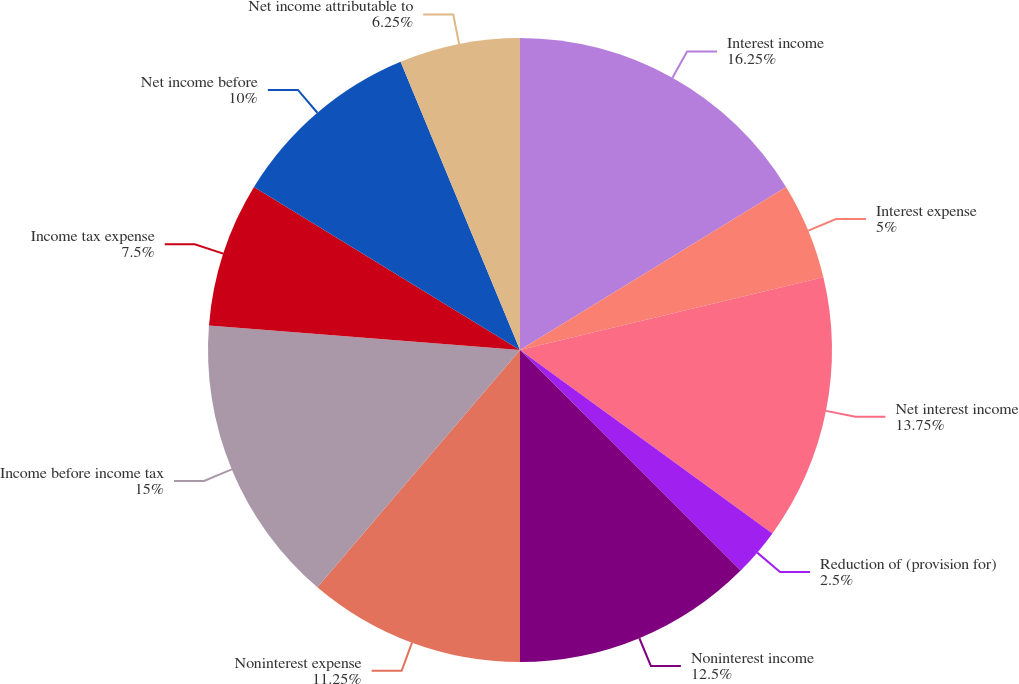Convert chart. <chart><loc_0><loc_0><loc_500><loc_500><pie_chart><fcel>Interest income<fcel>Interest expense<fcel>Net interest income<fcel>Reduction of (provision for)<fcel>Noninterest income<fcel>Noninterest expense<fcel>Income before income tax<fcel>Income tax expense<fcel>Net income before<fcel>Net income attributable to<nl><fcel>16.25%<fcel>5.0%<fcel>13.75%<fcel>2.5%<fcel>12.5%<fcel>11.25%<fcel>15.0%<fcel>7.5%<fcel>10.0%<fcel>6.25%<nl></chart> 